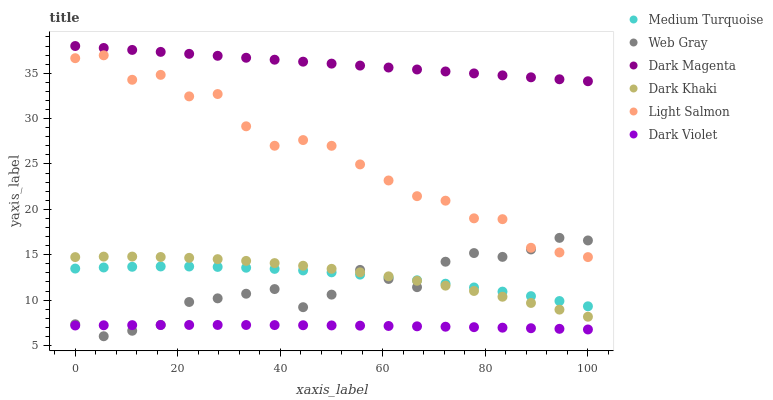Does Dark Violet have the minimum area under the curve?
Answer yes or no. Yes. Does Dark Magenta have the maximum area under the curve?
Answer yes or no. Yes. Does Web Gray have the minimum area under the curve?
Answer yes or no. No. Does Web Gray have the maximum area under the curve?
Answer yes or no. No. Is Dark Magenta the smoothest?
Answer yes or no. Yes. Is Light Salmon the roughest?
Answer yes or no. Yes. Is Web Gray the smoothest?
Answer yes or no. No. Is Web Gray the roughest?
Answer yes or no. No. Does Web Gray have the lowest value?
Answer yes or no. Yes. Does Dark Magenta have the lowest value?
Answer yes or no. No. Does Dark Magenta have the highest value?
Answer yes or no. Yes. Does Web Gray have the highest value?
Answer yes or no. No. Is Web Gray less than Dark Magenta?
Answer yes or no. Yes. Is Dark Magenta greater than Dark Khaki?
Answer yes or no. Yes. Does Web Gray intersect Dark Khaki?
Answer yes or no. Yes. Is Web Gray less than Dark Khaki?
Answer yes or no. No. Is Web Gray greater than Dark Khaki?
Answer yes or no. No. Does Web Gray intersect Dark Magenta?
Answer yes or no. No. 